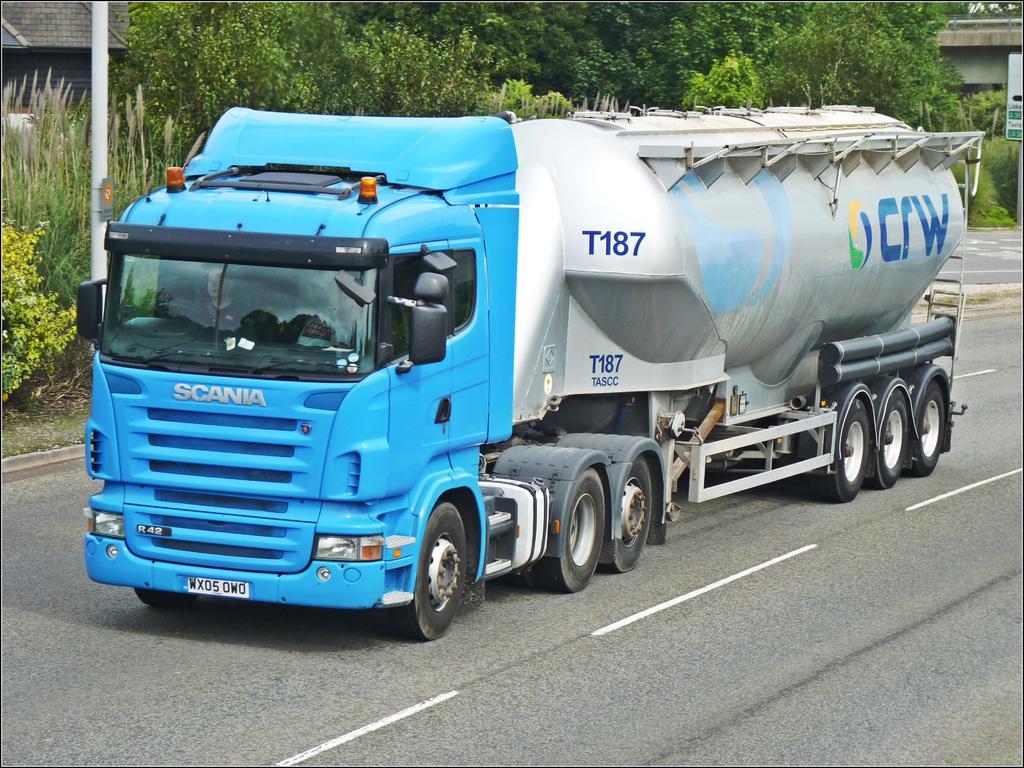Please provide a concise description of this image. This image consists of a truck. It is in blue color. At the bottom, there is a road. In the background, there are many trees along with a pole and houses. 